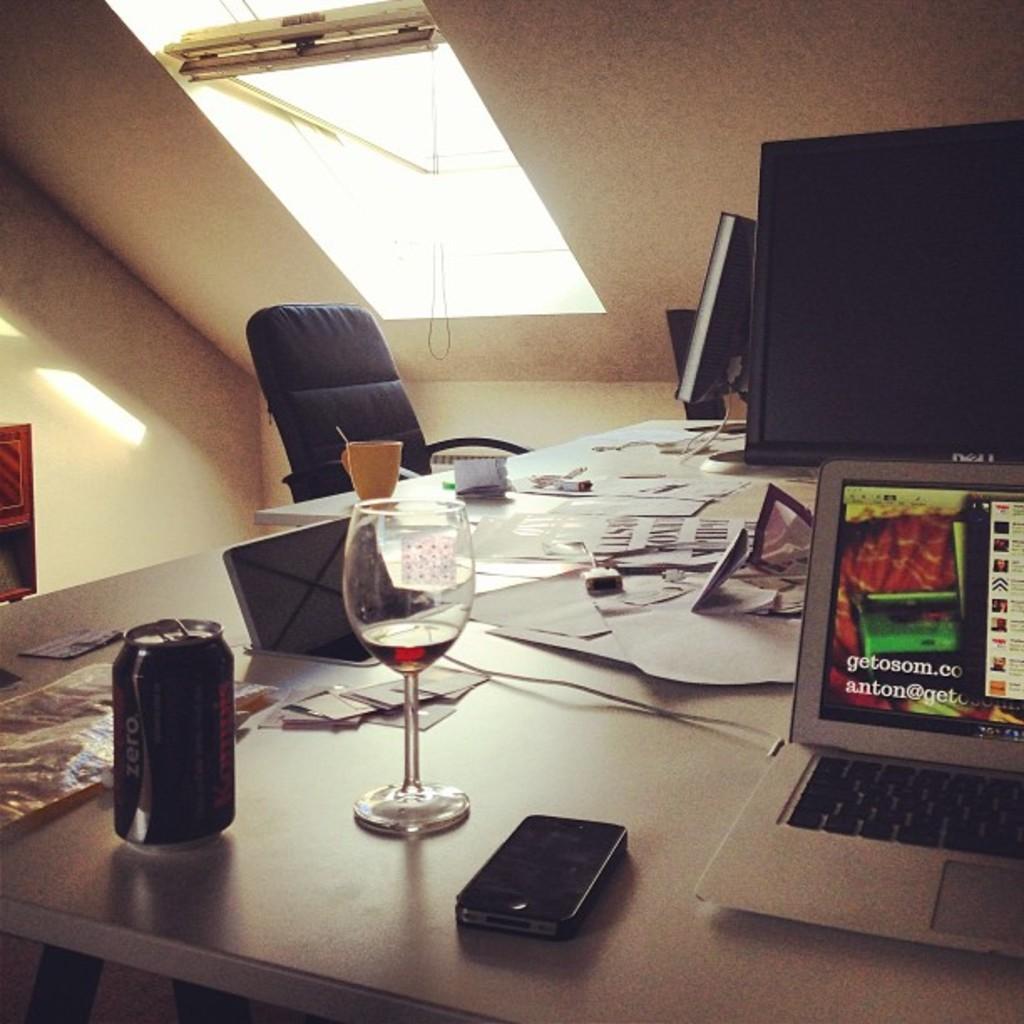How would you summarize this image in a sentence or two? We can see papers,glass,cup,in,laptop,monitors on the table. In front of this table we can see chair. On the top we can see light,On the background we can see wall. 